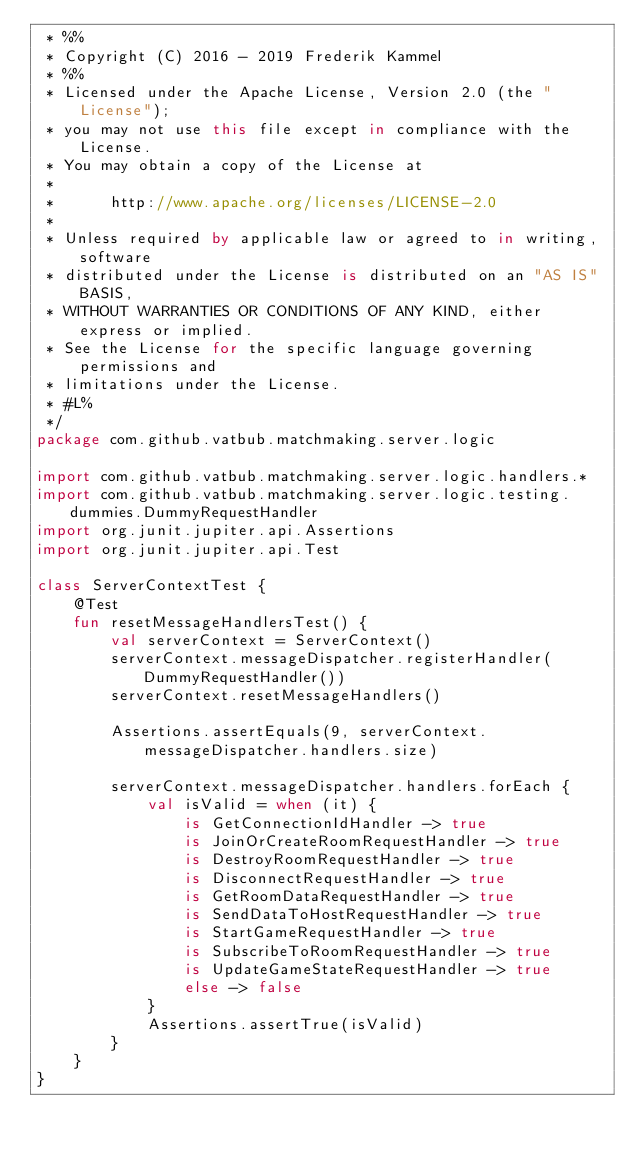<code> <loc_0><loc_0><loc_500><loc_500><_Kotlin_> * %%
 * Copyright (C) 2016 - 2019 Frederik Kammel
 * %%
 * Licensed under the Apache License, Version 2.0 (the "License");
 * you may not use this file except in compliance with the License.
 * You may obtain a copy of the License at
 * 
 *      http://www.apache.org/licenses/LICENSE-2.0
 * 
 * Unless required by applicable law or agreed to in writing, software
 * distributed under the License is distributed on an "AS IS" BASIS,
 * WITHOUT WARRANTIES OR CONDITIONS OF ANY KIND, either express or implied.
 * See the License for the specific language governing permissions and
 * limitations under the License.
 * #L%
 */
package com.github.vatbub.matchmaking.server.logic

import com.github.vatbub.matchmaking.server.logic.handlers.*
import com.github.vatbub.matchmaking.server.logic.testing.dummies.DummyRequestHandler
import org.junit.jupiter.api.Assertions
import org.junit.jupiter.api.Test

class ServerContextTest {
    @Test
    fun resetMessageHandlersTest() {
        val serverContext = ServerContext()
        serverContext.messageDispatcher.registerHandler(DummyRequestHandler())
        serverContext.resetMessageHandlers()

        Assertions.assertEquals(9, serverContext.messageDispatcher.handlers.size)

        serverContext.messageDispatcher.handlers.forEach {
            val isValid = when (it) {
                is GetConnectionIdHandler -> true
                is JoinOrCreateRoomRequestHandler -> true
                is DestroyRoomRequestHandler -> true
                is DisconnectRequestHandler -> true
                is GetRoomDataRequestHandler -> true
                is SendDataToHostRequestHandler -> true
                is StartGameRequestHandler -> true
                is SubscribeToRoomRequestHandler -> true
                is UpdateGameStateRequestHandler -> true
                else -> false
            }
            Assertions.assertTrue(isValid)
        }
    }
}
</code> 